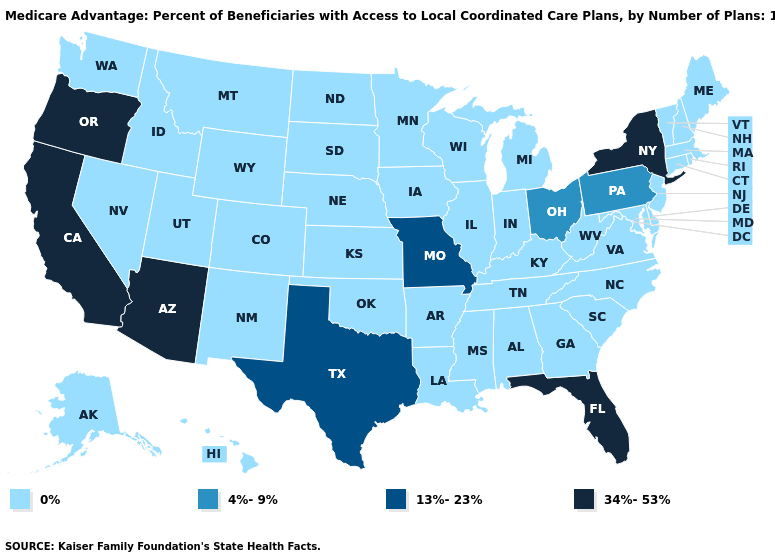Name the states that have a value in the range 4%-9%?
Answer briefly. Ohio, Pennsylvania. Does Louisiana have a higher value than New Mexico?
Short answer required. No. Name the states that have a value in the range 34%-53%?
Keep it brief. Arizona, California, Florida, New York, Oregon. What is the value of Texas?
Write a very short answer. 13%-23%. Name the states that have a value in the range 13%-23%?
Keep it brief. Missouri, Texas. Name the states that have a value in the range 4%-9%?
Write a very short answer. Ohio, Pennsylvania. Does the first symbol in the legend represent the smallest category?
Concise answer only. Yes. Name the states that have a value in the range 0%?
Quick response, please. Alaska, Alabama, Arkansas, Colorado, Connecticut, Delaware, Georgia, Hawaii, Iowa, Idaho, Illinois, Indiana, Kansas, Kentucky, Louisiana, Massachusetts, Maryland, Maine, Michigan, Minnesota, Mississippi, Montana, North Carolina, North Dakota, Nebraska, New Hampshire, New Jersey, New Mexico, Nevada, Oklahoma, Rhode Island, South Carolina, South Dakota, Tennessee, Utah, Virginia, Vermont, Washington, Wisconsin, West Virginia, Wyoming. What is the lowest value in the MidWest?
Short answer required. 0%. Does Virginia have a lower value than New York?
Be succinct. Yes. What is the value of Iowa?
Be succinct. 0%. Does Pennsylvania have the lowest value in the Northeast?
Be succinct. No. Does Massachusetts have a higher value than Delaware?
Be succinct. No. What is the value of Indiana?
Be succinct. 0%. Which states have the lowest value in the USA?
Concise answer only. Alaska, Alabama, Arkansas, Colorado, Connecticut, Delaware, Georgia, Hawaii, Iowa, Idaho, Illinois, Indiana, Kansas, Kentucky, Louisiana, Massachusetts, Maryland, Maine, Michigan, Minnesota, Mississippi, Montana, North Carolina, North Dakota, Nebraska, New Hampshire, New Jersey, New Mexico, Nevada, Oklahoma, Rhode Island, South Carolina, South Dakota, Tennessee, Utah, Virginia, Vermont, Washington, Wisconsin, West Virginia, Wyoming. 